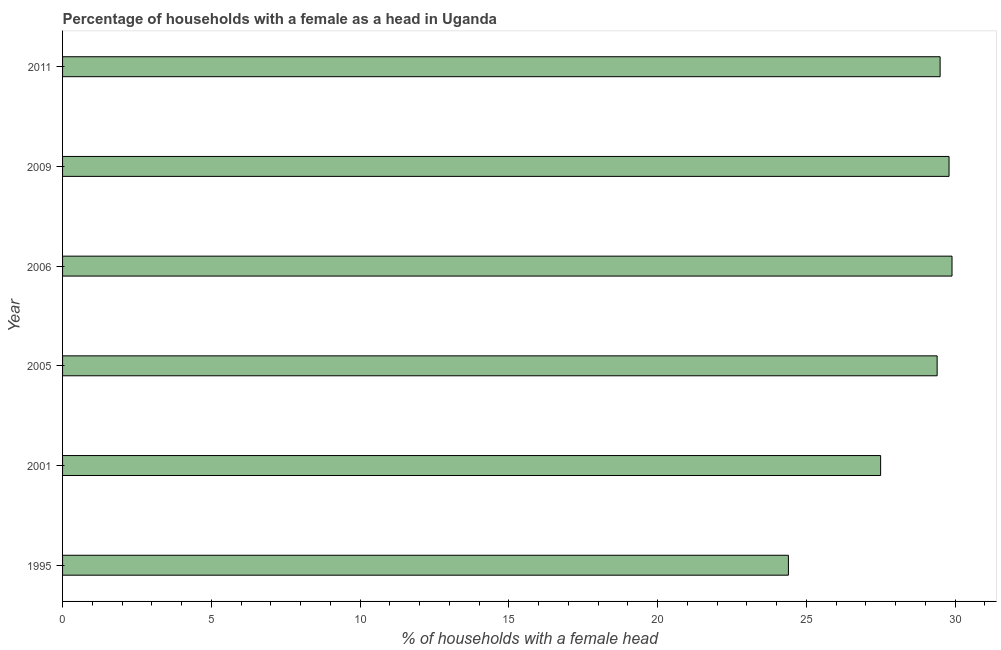What is the title of the graph?
Make the answer very short. Percentage of households with a female as a head in Uganda. What is the label or title of the X-axis?
Give a very brief answer. % of households with a female head. What is the number of female supervised households in 2005?
Give a very brief answer. 29.4. Across all years, what is the maximum number of female supervised households?
Provide a short and direct response. 29.9. Across all years, what is the minimum number of female supervised households?
Make the answer very short. 24.4. What is the sum of the number of female supervised households?
Your answer should be compact. 170.5. What is the difference between the number of female supervised households in 2006 and 2011?
Offer a very short reply. 0.4. What is the average number of female supervised households per year?
Your response must be concise. 28.42. What is the median number of female supervised households?
Offer a very short reply. 29.45. In how many years, is the number of female supervised households greater than 20 %?
Your response must be concise. 6. Do a majority of the years between 2001 and 2011 (inclusive) have number of female supervised households greater than 22 %?
Give a very brief answer. Yes. What is the ratio of the number of female supervised households in 2006 to that in 2011?
Make the answer very short. 1.01. What is the difference between the highest and the second highest number of female supervised households?
Ensure brevity in your answer.  0.1. In how many years, is the number of female supervised households greater than the average number of female supervised households taken over all years?
Your response must be concise. 4. How many bars are there?
Your answer should be very brief. 6. Are the values on the major ticks of X-axis written in scientific E-notation?
Provide a succinct answer. No. What is the % of households with a female head in 1995?
Give a very brief answer. 24.4. What is the % of households with a female head in 2001?
Offer a terse response. 27.5. What is the % of households with a female head in 2005?
Your response must be concise. 29.4. What is the % of households with a female head in 2006?
Ensure brevity in your answer.  29.9. What is the % of households with a female head of 2009?
Make the answer very short. 29.8. What is the % of households with a female head in 2011?
Your answer should be compact. 29.5. What is the difference between the % of households with a female head in 1995 and 2006?
Your answer should be very brief. -5.5. What is the difference between the % of households with a female head in 1995 and 2009?
Ensure brevity in your answer.  -5.4. What is the difference between the % of households with a female head in 1995 and 2011?
Give a very brief answer. -5.1. What is the difference between the % of households with a female head in 2001 and 2005?
Your answer should be compact. -1.9. What is the difference between the % of households with a female head in 2001 and 2006?
Ensure brevity in your answer.  -2.4. What is the difference between the % of households with a female head in 2005 and 2009?
Offer a very short reply. -0.4. What is the difference between the % of households with a female head in 2006 and 2009?
Your answer should be very brief. 0.1. What is the difference between the % of households with a female head in 2009 and 2011?
Ensure brevity in your answer.  0.3. What is the ratio of the % of households with a female head in 1995 to that in 2001?
Your response must be concise. 0.89. What is the ratio of the % of households with a female head in 1995 to that in 2005?
Give a very brief answer. 0.83. What is the ratio of the % of households with a female head in 1995 to that in 2006?
Ensure brevity in your answer.  0.82. What is the ratio of the % of households with a female head in 1995 to that in 2009?
Your answer should be very brief. 0.82. What is the ratio of the % of households with a female head in 1995 to that in 2011?
Offer a terse response. 0.83. What is the ratio of the % of households with a female head in 2001 to that in 2005?
Offer a very short reply. 0.94. What is the ratio of the % of households with a female head in 2001 to that in 2006?
Offer a very short reply. 0.92. What is the ratio of the % of households with a female head in 2001 to that in 2009?
Give a very brief answer. 0.92. What is the ratio of the % of households with a female head in 2001 to that in 2011?
Your response must be concise. 0.93. What is the ratio of the % of households with a female head in 2005 to that in 2006?
Ensure brevity in your answer.  0.98. What is the ratio of the % of households with a female head in 2005 to that in 2009?
Your answer should be very brief. 0.99. What is the ratio of the % of households with a female head in 2009 to that in 2011?
Give a very brief answer. 1.01. 